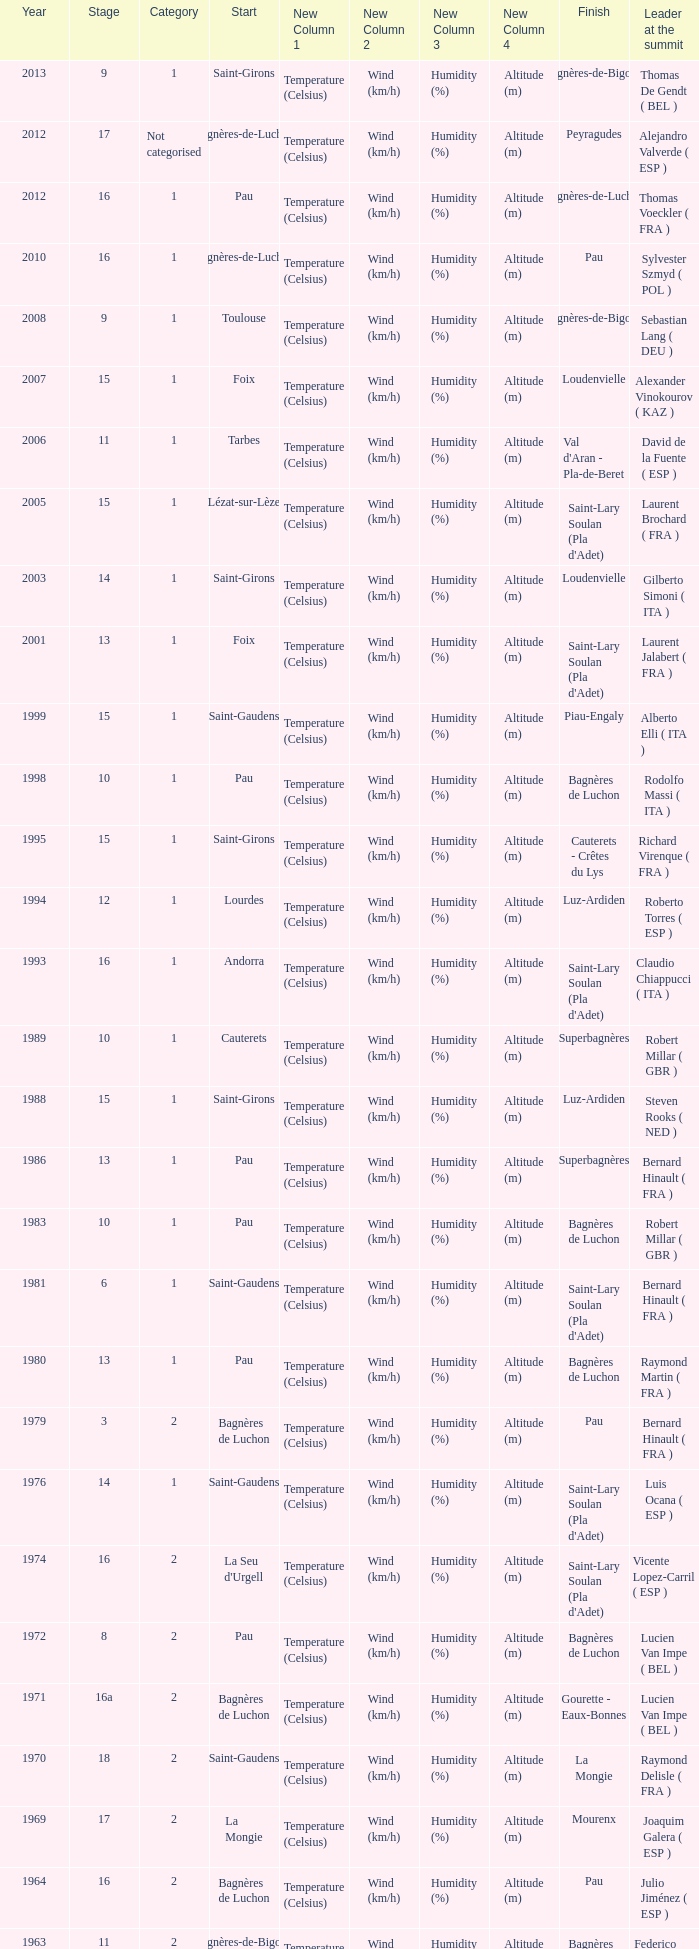What category was in 1964? 2.0. 